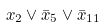Convert formula to latex. <formula><loc_0><loc_0><loc_500><loc_500>x _ { 2 } \vee \bar { x } _ { 5 } \vee \bar { x } _ { 1 1 }</formula> 